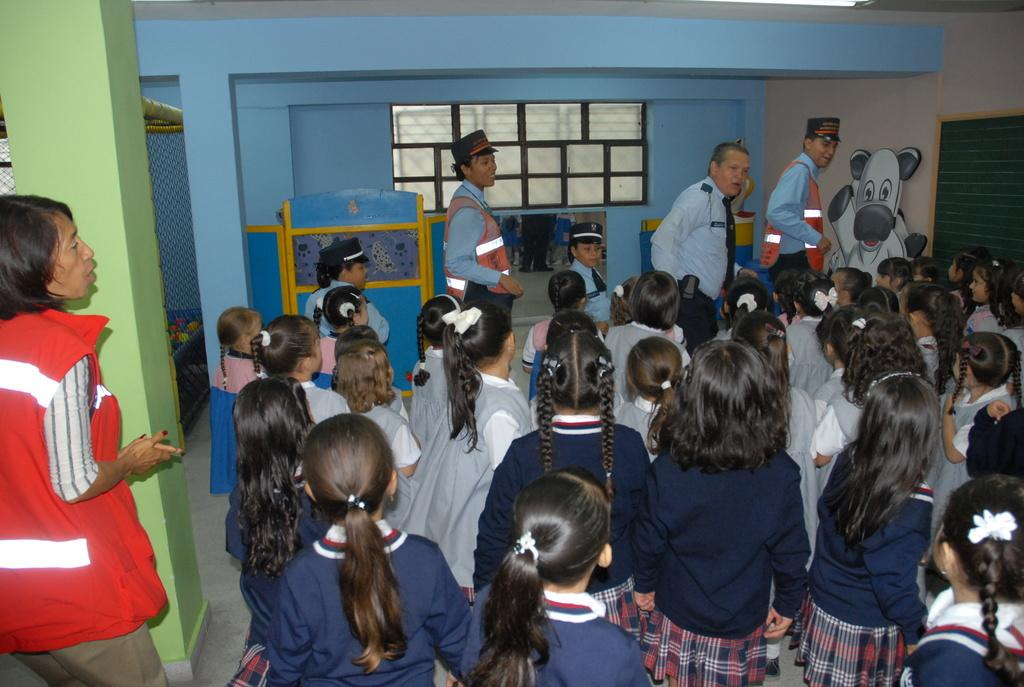What color is the wall in the image? The wall in the image is blue. What feature allows light and air to enter the room in the image? There is a window in the image. Who or what can be seen in the image? There is a group of people in the image. What can be seen on the left side of the image in the background? The background on the left side contains a net. What type of bridge can be seen in the image? There is no bridge present in the image. Is there a gun visible in the image? There is no gun visible in the image. 